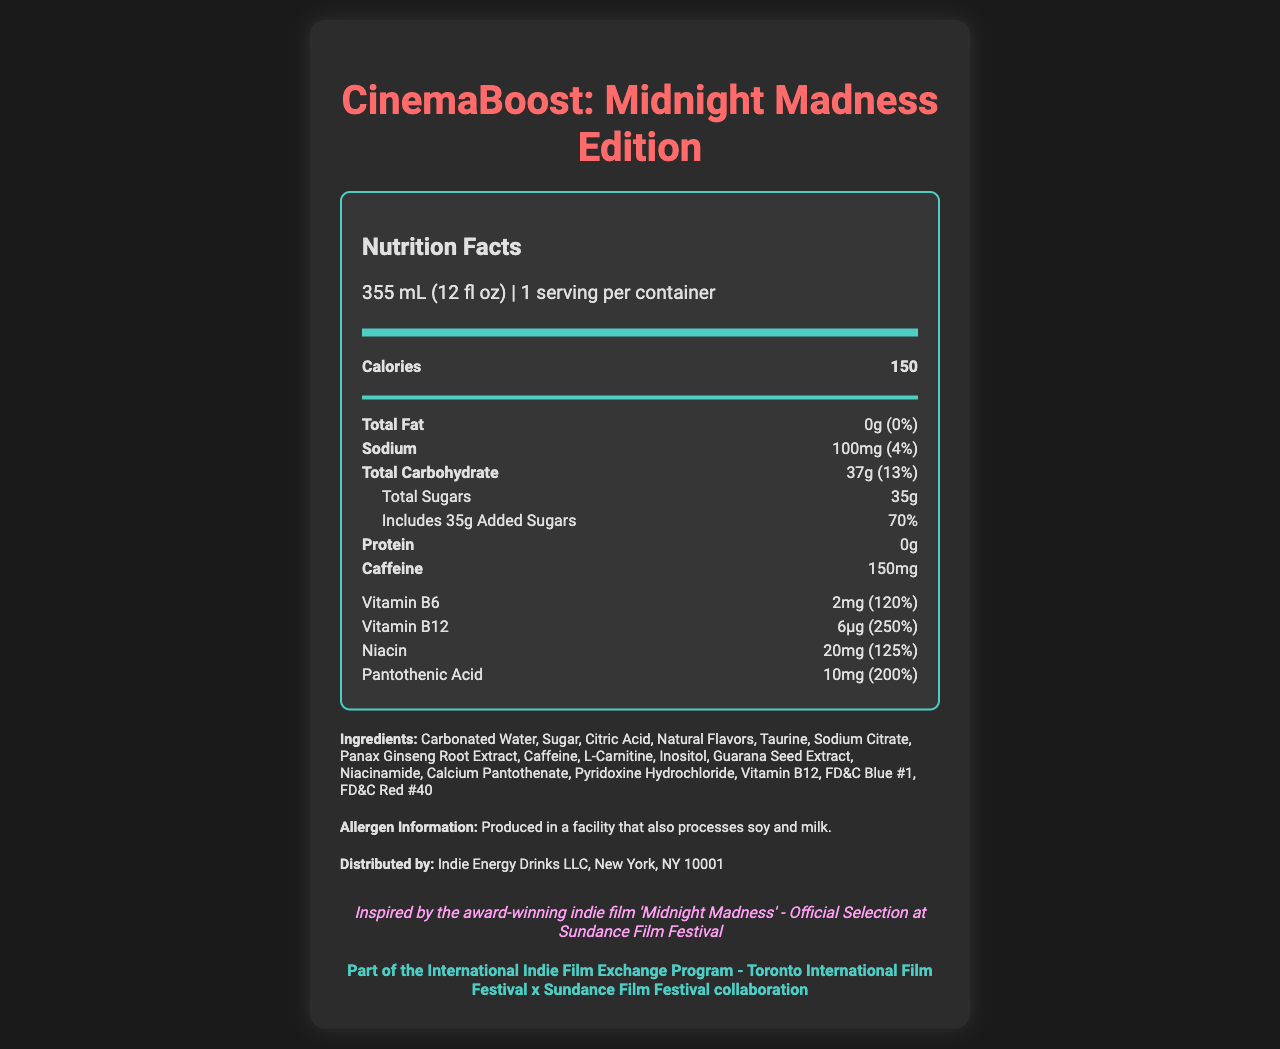What is the name of the product? The product name is displayed at the top of the document.
Answer: CinemaBoost: Midnight Madness Edition What is the serving size of the CinemaBoost energy drink? The serving size is mentioned in the serving info section under the Nutrition Facts header.
Answer: 355 mL (12 fl oz) How many calories are there per serving? The number of calories is stated in the main nutrients section under the bolded 'Calories' label.
Answer: 150 How much caffeine does this energy drink contain? The caffeine content is listed in the nutrient-row section as "Caffeine."
Answer: 150mg What is the percentage of daily value for Niacin provided by this product? The daily value percentage for Niacin is given in the vitamins and minerals section.
Answer: 125% Which of the following ingredients is not included in the CinemaBoost energy drink? A. Taurine B. Sodium Citrate C. Ascorbic Acid D. Caffeine Ascorbic Acid is not listed in the ingredients section, whereas Taurine, Sodium Citrate, and Caffeine are.
Answer: C. Ascorbic Acid What percentage of the daily value for Vitamin B12 does this energy drink provide? A. 120% B. 200% C. 150% D. 250% The daily value for Vitamin B12 is stated as 250% in the vitamins and minerals section.
Answer: D. 250% Does this energy drink contain any protein? The protein amount is listed as 0g in the nutrient-row section.
Answer: No Is it clear whether the product contains dairy ingredients? The allergen information states that it is produced in a facility that processes soy and milk, but it does not explicitly state that the product itself contains dairy ingredients.
Answer: No Summarize the main purpose of this document. The document primarily serves to inform consumers about the nutritional content of the CinemaBoost energy drink, its ingredients, and its associations with indie films. It also mentions the distributor and marketing details.
Answer: This document provides the Nutrition Facts and ingredient information for the limited-edition energy drink 'CinemaBoost: Midnight Madness Edition.' It highlights the serving size, calories, main nutrients, and vitamins and minerals content, along with ingredient and allergen information. Inspired by an award-winning indie film, the product is part of an international film exchange program. What is the distribution company for this product? The distributor information is found in the section labeled "Distributed by."
Answer: Indie Energy Drinks LLC, New York, NY 10001 How much added sugar does this product contain, and what is its daily value percentage? The amount of added sugars and its daily value percentage are listed in the section under "Includes 35g Added Sugars."
Answer: 35g, 70% Can it be determined from the document how long the limited edition will be available? The document does not include any information about the duration of the limited edition's availability.
Answer: Cannot be determined 